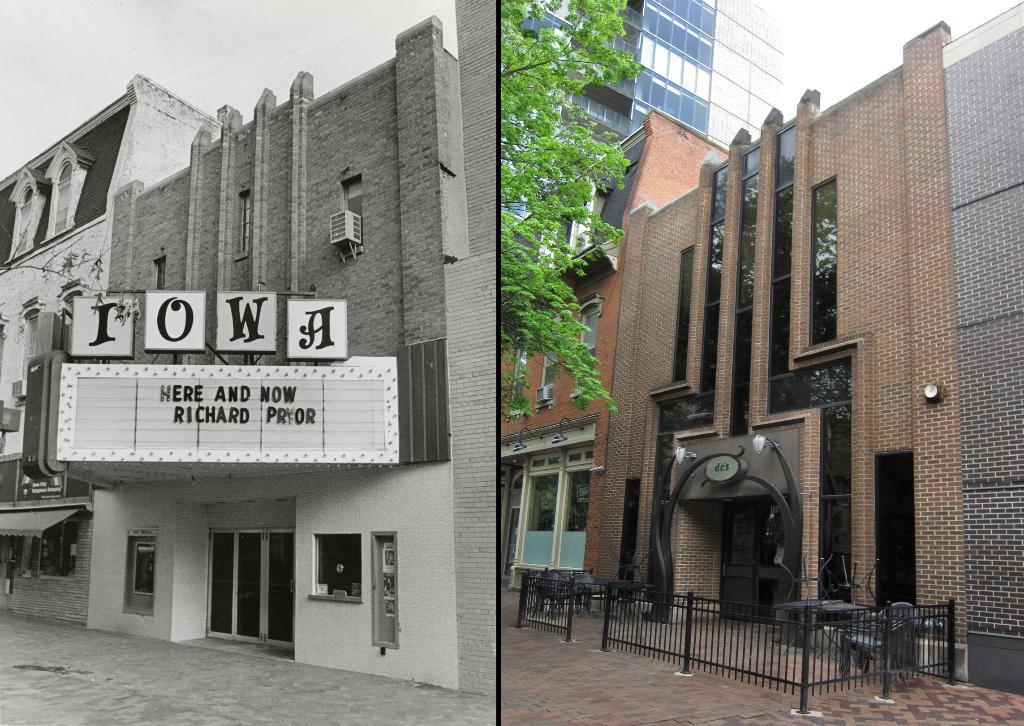What type of image is shown in the collage? The image is a photo collage. What can be seen on the left side of the collage? There is a building with a name on the left side of the collage. What is depicted on the right side of the collage? There is a building with glasses on the right side of the collage. Are there any natural elements in the collage? Yes, there is a tree in the image. What type of crayon is being used to draw the buildings in the collage? There is no crayon present in the collage; it is a collection of photographs. What religion is depicted in the collage? There is no specific religion depicted in the collage; it features buildings and a tree. 